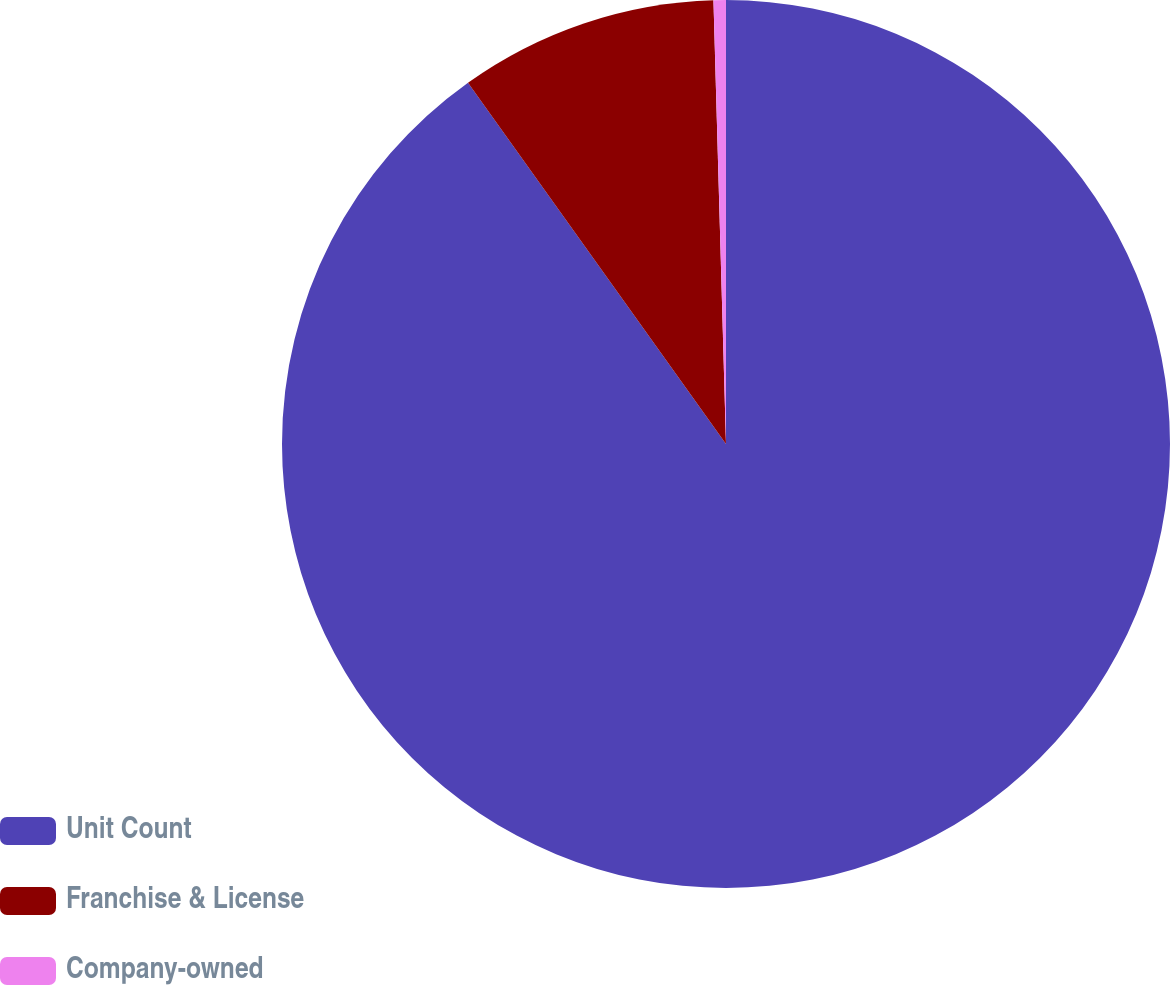<chart> <loc_0><loc_0><loc_500><loc_500><pie_chart><fcel>Unit Count<fcel>Franchise & License<fcel>Company-owned<nl><fcel>90.14%<fcel>9.42%<fcel>0.45%<nl></chart> 